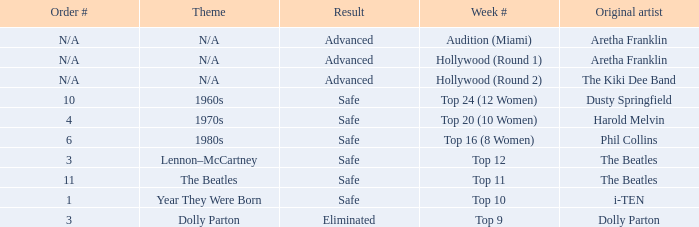What is the order number that has Aretha Franklin as the original artist? N/A, N/A. 